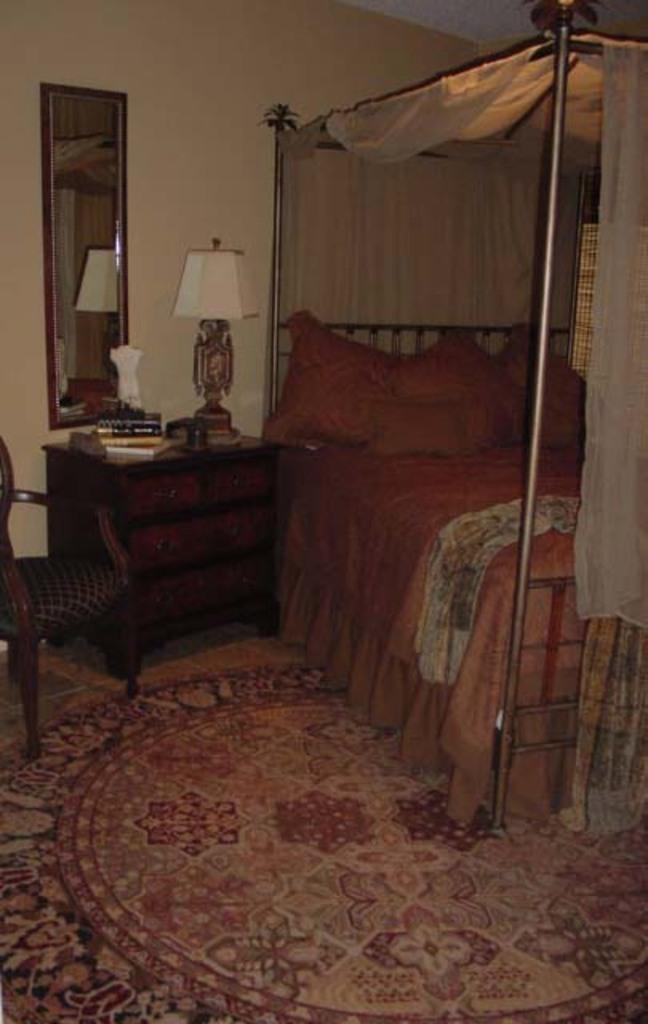Can you describe this image briefly? In this Image I see a bed, a drawer on which there are few things and a lamp, a mirror and a chair. 